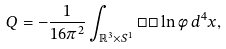<formula> <loc_0><loc_0><loc_500><loc_500>Q = - \frac { 1 } { 1 6 \pi ^ { 2 } } \int _ { \mathbb { R } ^ { 3 } \times S ^ { 1 } } \Box \Box \ln \phi \, d ^ { 4 } x ,</formula> 